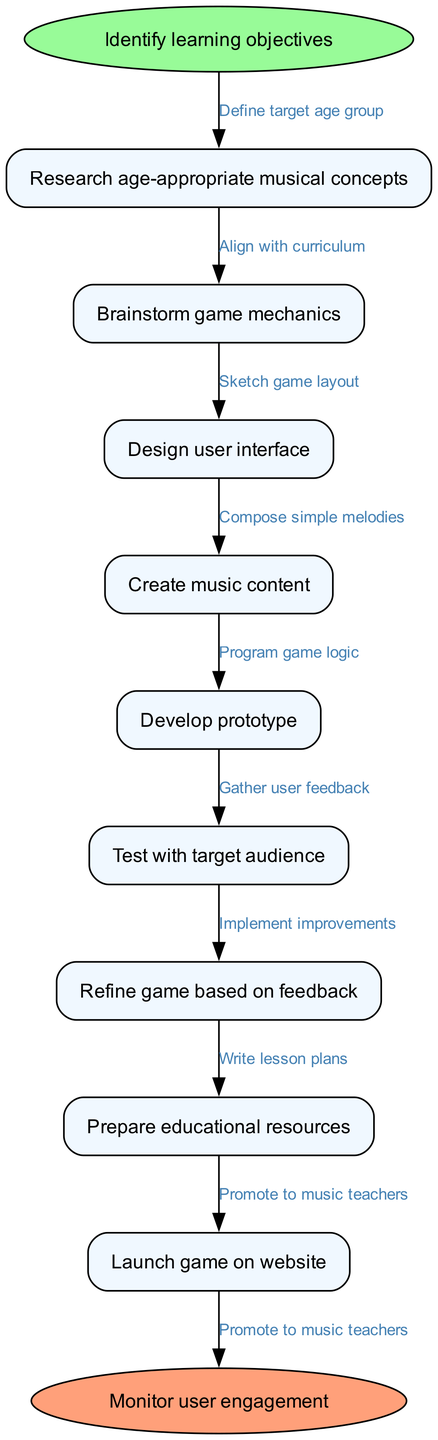What is the first step in the workflow? The first step is indicated as the starting point of the flow chart, which is "Identify learning objectives." This node is directly connected to the start node.
Answer: Identify learning objectives How many nodes are there in total? The diagram consists of one start node, eight intermediate nodes, and one end node. When counted together, that adds up to a total of ten nodes.
Answer: 10 What is the last step before launching the game? The last step before the end node is "Refine game based on feedback." This is the final action taken before monitoring user engagement.
Answer: Refine game based on feedback Which node comes after "Create music content"? By following the flow of the diagram, "Develop prototype" is the node that follows "Create music content." It is the next step in the workflow sequence.
Answer: Develop prototype How many edges connect the nodes in the diagram? The diagram includes eight edges connecting the nine nodes (not counting the start and end nodes). Each edge signifies a relationship between nodes, showing the progression of the workflow from one step to another.
Answer: 8 What is the purpose of the "Test with target audience" step? "Test with target audience" is a step meant to gather user feedback about the game. It ensures that the game meets the needs and interests of the learners it is intended for.
Answer: Gather user feedback Which step is directly linked to "Launch game on website"? The step directly connected to "Launch game on website" is "Prepare educational resources." This suggests that preparations for educational materials must occur before launching the game.
Answer: Prepare educational resources Which node is connected to "Monitor user engagement"? "Monitor user engagement" is the ending node that follows "Launch game on website." This illustrates that after launching, the focus shifts to observing how users interact with the game.
Answer: Launch game on website 